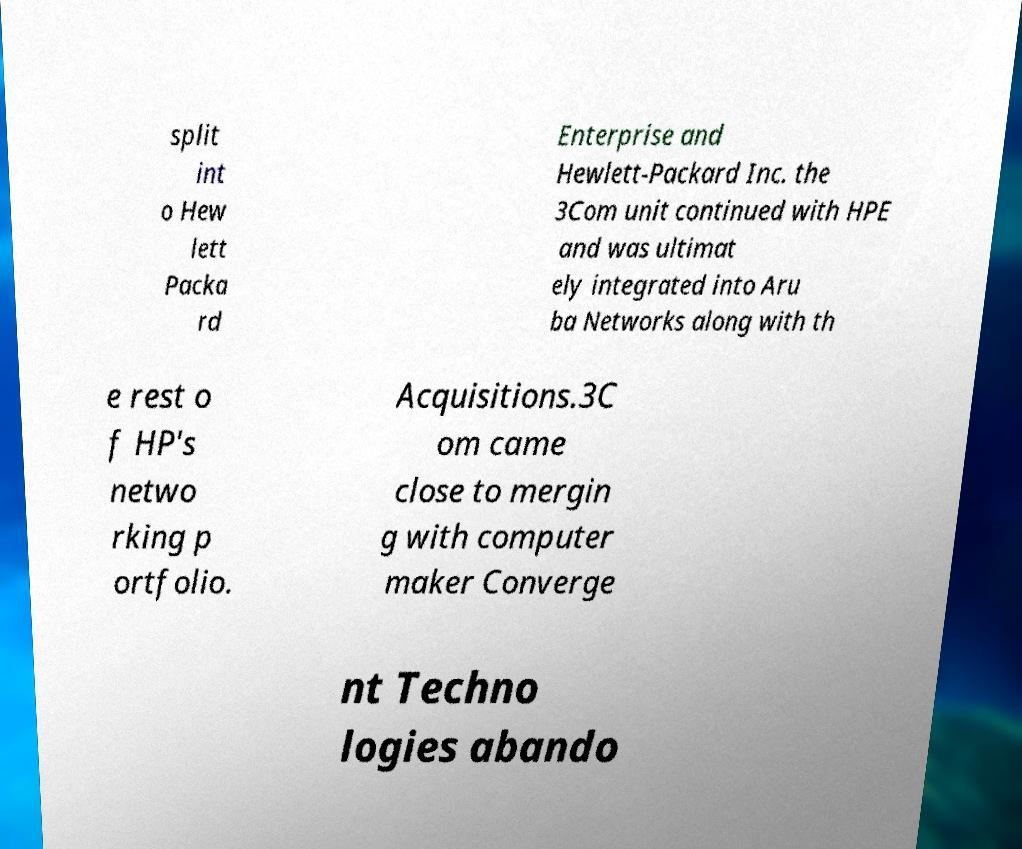What messages or text are displayed in this image? I need them in a readable, typed format. split int o Hew lett Packa rd Enterprise and Hewlett-Packard Inc. the 3Com unit continued with HPE and was ultimat ely integrated into Aru ba Networks along with th e rest o f HP's netwo rking p ortfolio. Acquisitions.3C om came close to mergin g with computer maker Converge nt Techno logies abando 